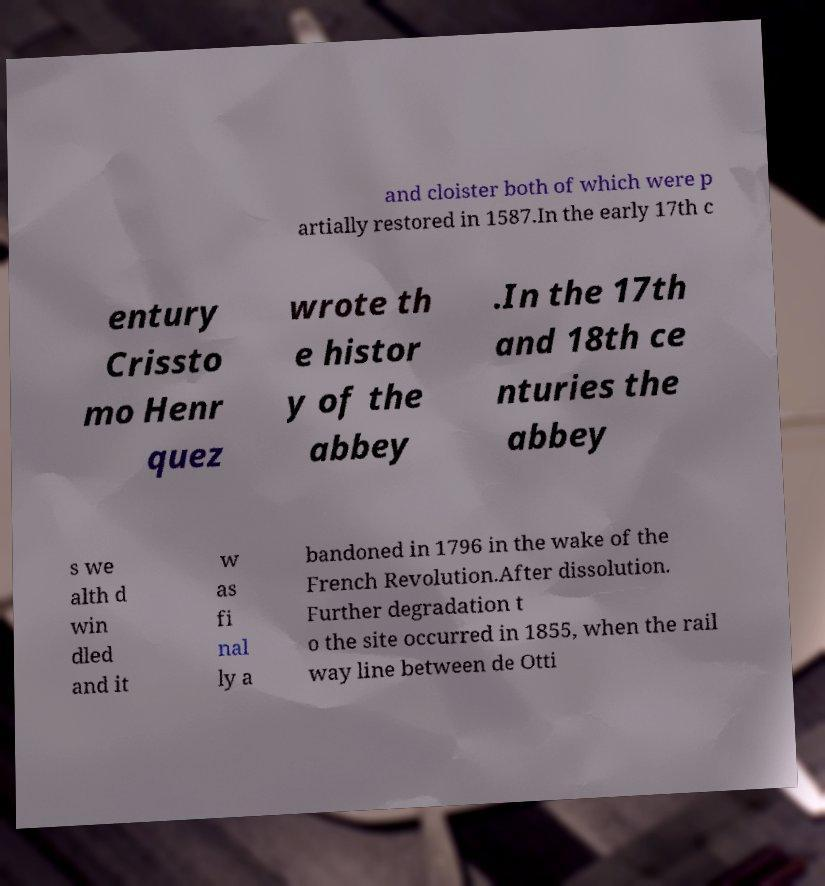For documentation purposes, I need the text within this image transcribed. Could you provide that? and cloister both of which were p artially restored in 1587.In the early 17th c entury Crissto mo Henr quez wrote th e histor y of the abbey .In the 17th and 18th ce nturies the abbey s we alth d win dled and it w as fi nal ly a bandoned in 1796 in the wake of the French Revolution.After dissolution. Further degradation t o the site occurred in 1855, when the rail way line between de Otti 